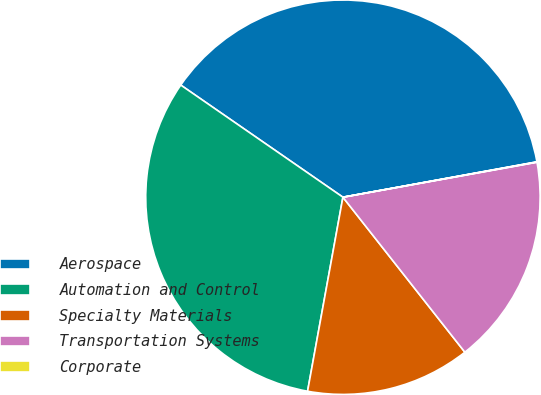Convert chart to OTSL. <chart><loc_0><loc_0><loc_500><loc_500><pie_chart><fcel>Aerospace<fcel>Automation and Control<fcel>Specialty Materials<fcel>Transportation Systems<fcel>Corporate<nl><fcel>37.5%<fcel>31.76%<fcel>13.48%<fcel>17.23%<fcel>0.03%<nl></chart> 